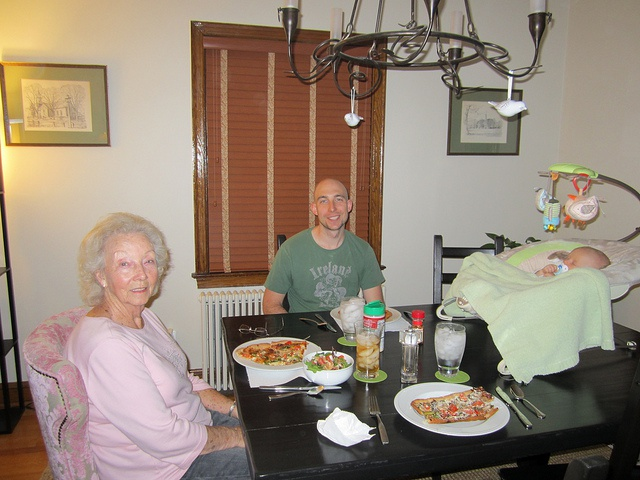Describe the objects in this image and their specific colors. I can see dining table in tan, black, gray, lightgray, and darkgray tones, people in tan, lavender, darkgray, lightpink, and pink tones, people in tan, gray, salmon, and darkgray tones, chair in tan, darkgray, lightpink, and gray tones, and pizza in tan, darkgray, and brown tones in this image. 